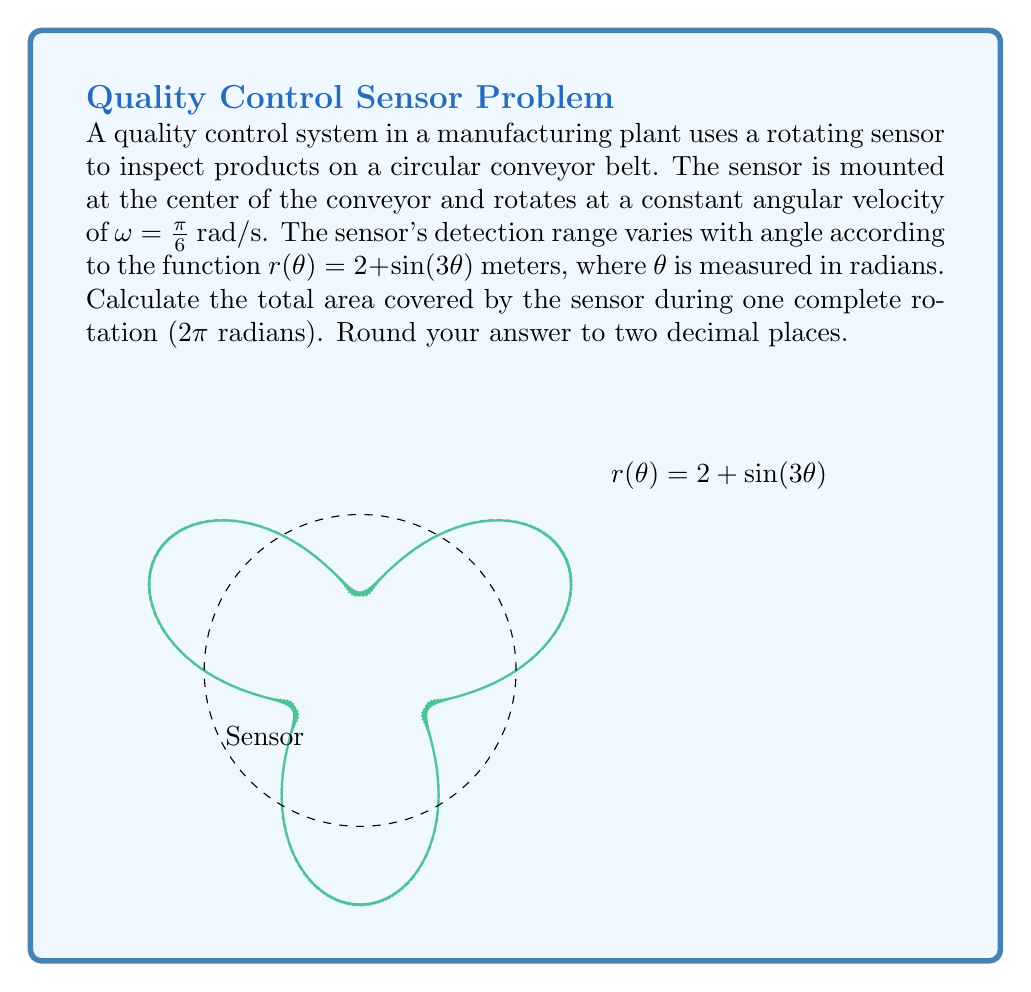Can you answer this question? To solve this problem, we'll use the formula for the area of a polar region:

$$A = \frac{1}{2} \int_0^{2\pi} [r(\theta)]^2 d\theta$$

Step 1: Substitute the given function into the formula.
$$A = \frac{1}{2} \int_0^{2\pi} [2 + \sin(3\theta)]^2 d\theta$$

Step 2: Expand the squared term.
$$A = \frac{1}{2} \int_0^{2\pi} [4 + 4\sin(3\theta) + \sin^2(3\theta)] d\theta$$

Step 3: Integrate each term separately.
- $\int_0^{2\pi} 4 d\theta = 4\theta \big|_0^{2\pi} = 8\pi$
- $\int_0^{2\pi} 4\sin(3\theta) d\theta = -\frac{4}{3}\cos(3\theta) \big|_0^{2\pi} = 0$
- $\int_0^{2\pi} \sin^2(3\theta) d\theta = \int_0^{2\pi} \frac{1 - \cos(6\theta)}{2} d\theta = \frac{\theta}{2} - \frac{\sin(6\theta)}{12} \big|_0^{2\pi} = \pi$

Step 4: Sum up the results and multiply by $\frac{1}{2}$.
$$A = \frac{1}{2} (8\pi + 0 + \pi) = \frac{9\pi}{2} \approx 14.14 \text{ m}^2$$

Step 5: Round to two decimal places.
The final answer is 14.14 m².
Answer: 14.14 m² 